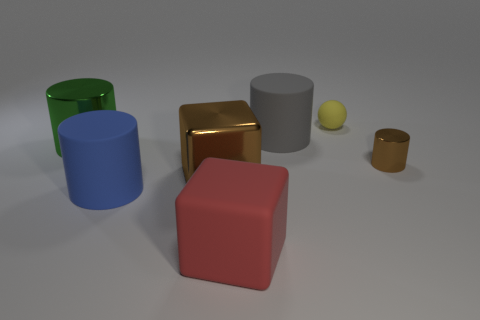Subtract 1 cylinders. How many cylinders are left? 3 Subtract all red cylinders. Subtract all brown blocks. How many cylinders are left? 4 Add 2 blue cylinders. How many objects exist? 9 Subtract all cubes. How many objects are left? 5 Add 5 brown blocks. How many brown blocks are left? 6 Add 5 big green objects. How many big green objects exist? 6 Subtract 0 red cylinders. How many objects are left? 7 Subtract all big red matte things. Subtract all red matte balls. How many objects are left? 6 